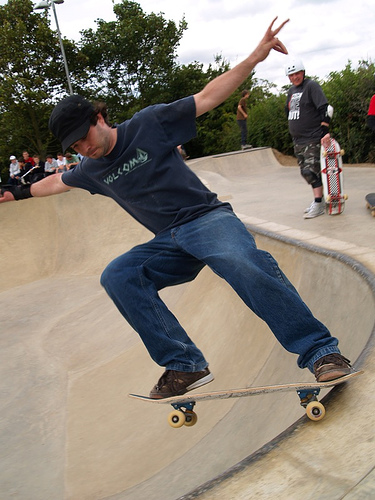Please transcribe the text in this image. WELCOMES 